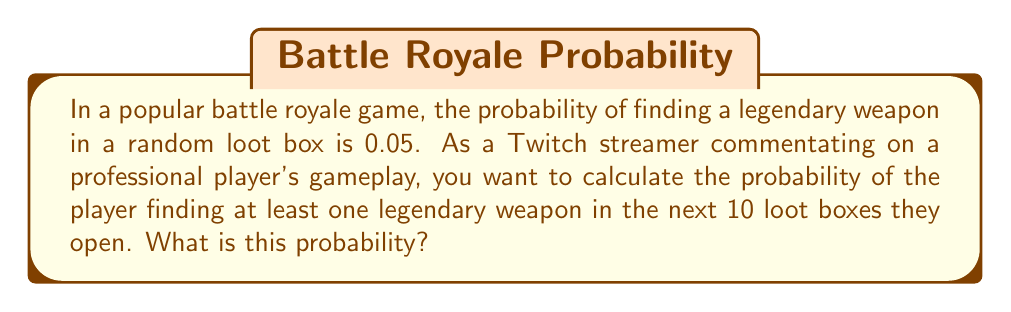Give your solution to this math problem. Let's approach this step-by-step:

1) First, we need to find the probability of not finding a legendary weapon in a single loot box. This is the complement of the given probability:

   $P(\text{no legendary weapon}) = 1 - 0.05 = 0.95$

2) Now, we need to calculate the probability of not finding a legendary weapon in all 10 loot boxes. Since each loot box is independent, we multiply these probabilities:

   $P(\text{no legendary weapon in 10 boxes}) = 0.95^{10}$

3) The question asks for the probability of finding at least one legendary weapon. This is the complement of finding no legendary weapons:

   $P(\text{at least one legendary weapon}) = 1 - P(\text{no legendary weapon in 10 boxes})$

4) Let's calculate this:

   $P(\text{at least one legendary weapon}) = 1 - 0.95^{10}$

5) Now we can compute the final result:

   $1 - 0.95^{10} = 1 - 0.5987 = 0.4013$

6) This can be expressed as a percentage:

   $0.4013 \times 100\% = 40.13\%$
Answer: $40.13\%$ 